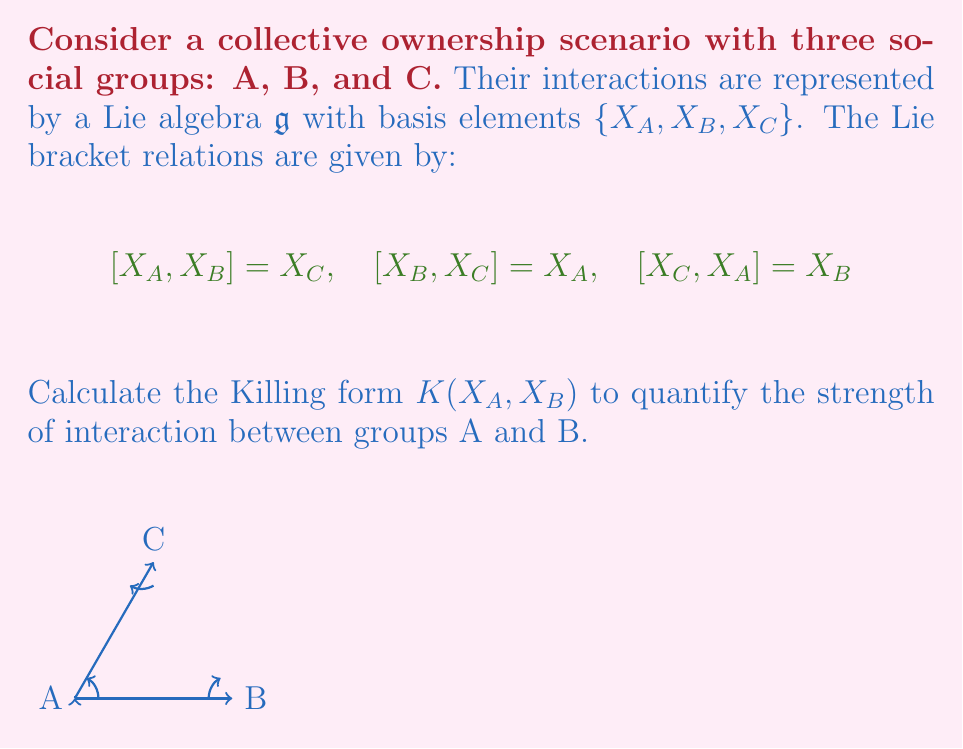Solve this math problem. To calculate the Killing form $K(X_A, X_B)$, we need to follow these steps:

1) The Killing form is defined as $K(X,Y) = \text{tr}(\text{ad}_X \circ \text{ad}_Y)$, where $\text{ad}_X$ is the adjoint representation of $X$.

2) First, we need to find the matrix representations of $\text{ad}_{X_A}$ and $\text{ad}_{X_B}$.

3) For $\text{ad}_{X_A}$:
   $\text{ad}_{X_A}(X_A) = 0$
   $\text{ad}_{X_A}(X_B) = [X_A, X_B] = X_C$
   $\text{ad}_{X_A}(X_C) = [X_A, X_C] = -X_B$

   So, $\text{ad}_{X_A} = \begin{pmatrix} 0 & 0 & 0 \\ 0 & 0 & -1 \\ 0 & 1 & 0 \end{pmatrix}$

4) For $\text{ad}_{X_B}$:
   $\text{ad}_{X_B}(X_A) = [X_B, X_A] = -X_C$
   $\text{ad}_{X_B}(X_B) = 0$
   $\text{ad}_{X_B}(X_C) = [X_B, X_C] = X_A$

   So, $\text{ad}_{X_B} = \begin{pmatrix} 0 & 0 & 1 \\ 0 & 0 & 0 \\ -1 & 0 & 0 \end{pmatrix}$

5) Now we compute $\text{ad}_{X_A} \circ \text{ad}_{X_B}$:

   $\text{ad}_{X_A} \circ \text{ad}_{X_B} = \begin{pmatrix} 0 & 0 & 0 \\ 0 & 0 & -1 \\ 0 & 1 & 0 \end{pmatrix} \begin{pmatrix} 0 & 0 & 1 \\ 0 & 0 & 0 \\ -1 & 0 & 0 \end{pmatrix} = \begin{pmatrix} 0 & 0 & 0 \\ 1 & 0 & 0 \\ 0 & 0 & 0 \end{pmatrix}$

6) The Killing form $K(X_A, X_B)$ is the trace of this matrix:

   $K(X_A, X_B) = \text{tr}(\text{ad}_{X_A} \circ \text{ad}_{X_B}) = 0$
Answer: $K(X_A, X_B) = 0$ 